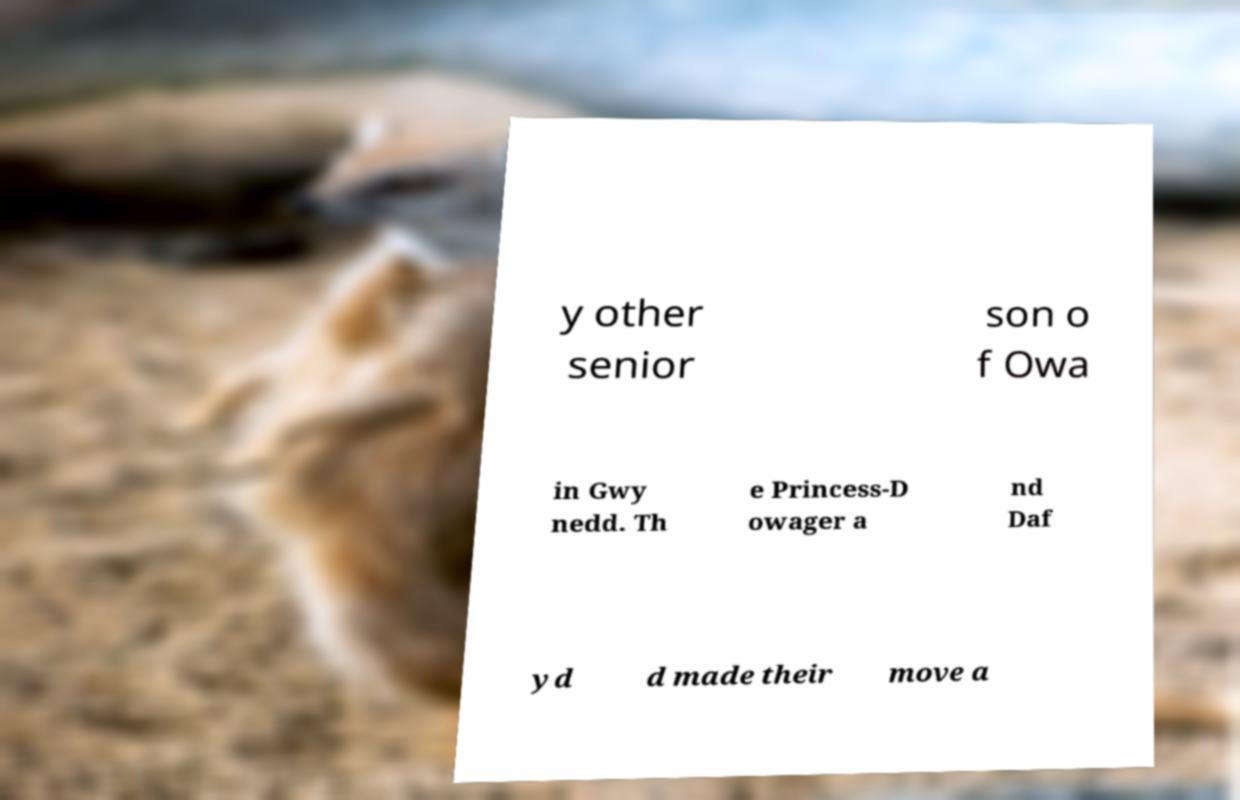Could you extract and type out the text from this image? y other senior son o f Owa in Gwy nedd. Th e Princess-D owager a nd Daf yd d made their move a 